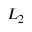<formula> <loc_0><loc_0><loc_500><loc_500>L _ { 2 }</formula> 